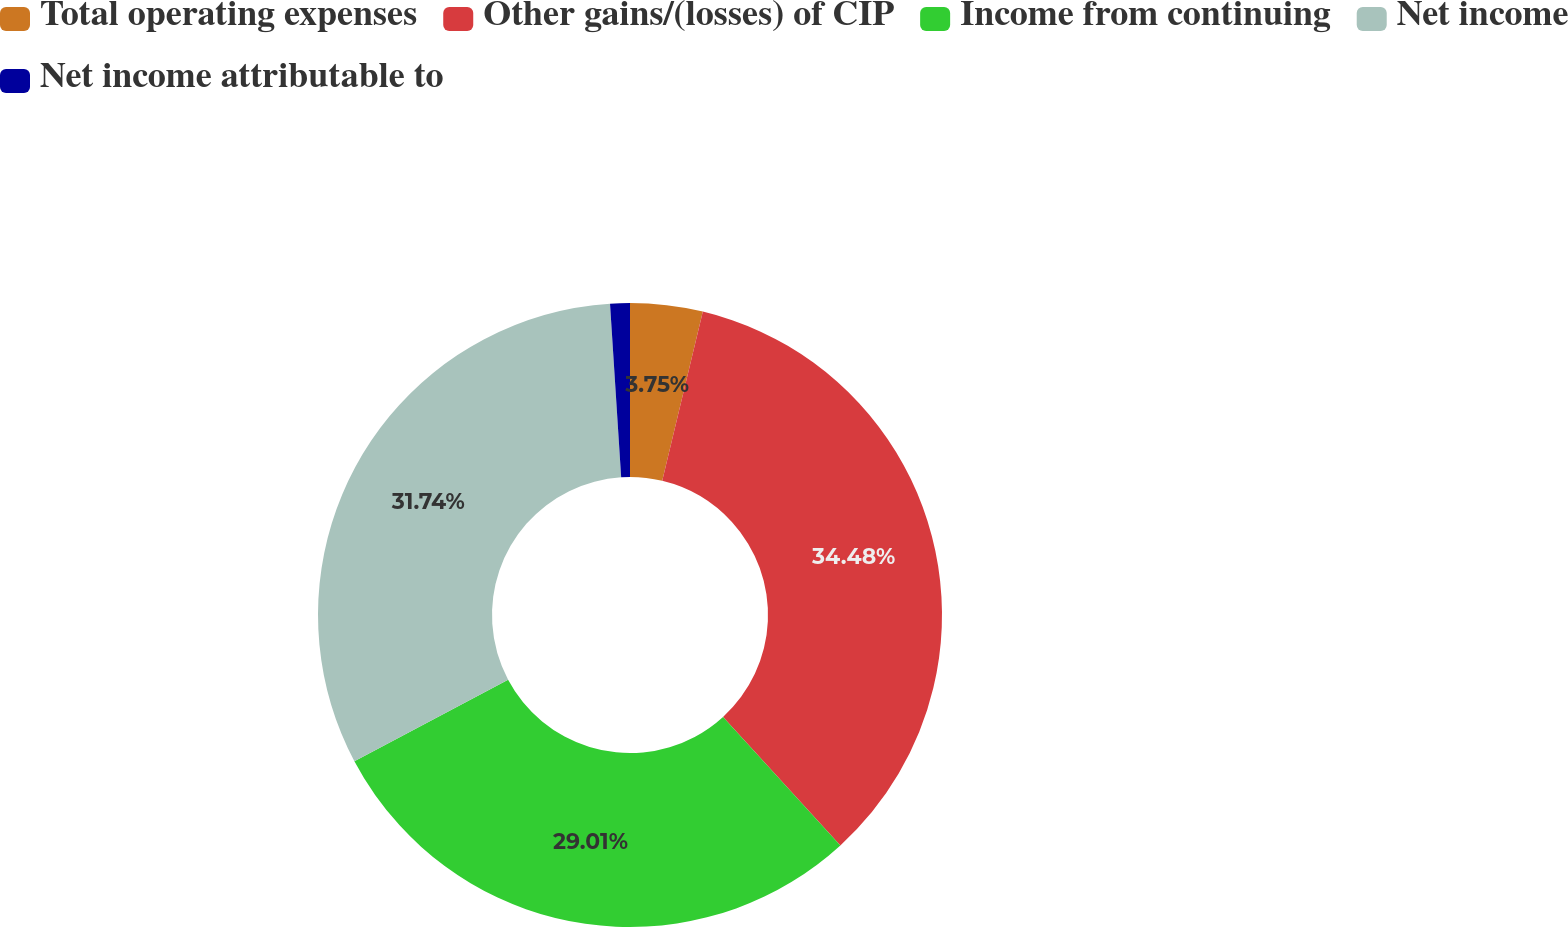<chart> <loc_0><loc_0><loc_500><loc_500><pie_chart><fcel>Total operating expenses<fcel>Other gains/(losses) of CIP<fcel>Income from continuing<fcel>Net income<fcel>Net income attributable to<nl><fcel>3.75%<fcel>34.47%<fcel>29.01%<fcel>31.74%<fcel>1.02%<nl></chart> 